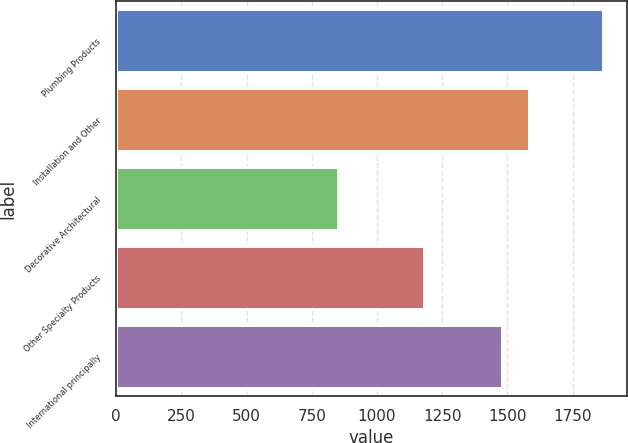Convert chart. <chart><loc_0><loc_0><loc_500><loc_500><bar_chart><fcel>Plumbing Products<fcel>Installation and Other<fcel>Decorative Architectural<fcel>Other Specialty Products<fcel>International principally<nl><fcel>1866<fcel>1582.5<fcel>851<fcel>1182<fcel>1481<nl></chart> 